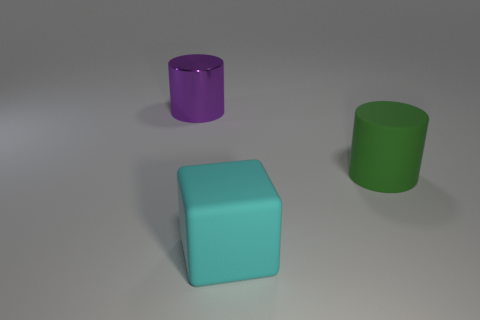How many other things are the same size as the green matte cylinder?
Give a very brief answer. 2. What size is the thing that is both on the left side of the big green matte cylinder and behind the big block?
Provide a succinct answer. Large. What number of other big green things have the same shape as the large green object?
Offer a very short reply. 0. What is the material of the cyan cube?
Offer a very short reply. Rubber. Is the big green thing the same shape as the large metal thing?
Offer a terse response. Yes. Are there any big cyan objects that have the same material as the cube?
Ensure brevity in your answer.  No. What color is the big object that is both to the left of the large green cylinder and right of the metal object?
Your response must be concise. Cyan. What is the material of the thing left of the cyan rubber cube?
Your answer should be very brief. Metal. Are there any other large purple shiny objects that have the same shape as the large purple object?
Provide a succinct answer. No. What number of other things are the same shape as the large purple thing?
Ensure brevity in your answer.  1. 